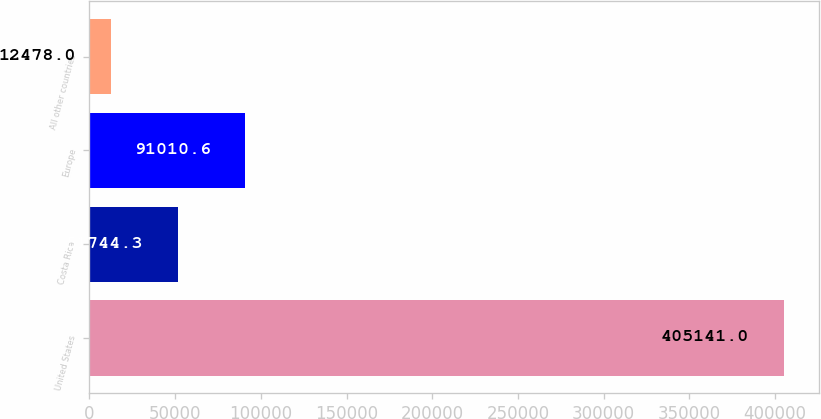Convert chart. <chart><loc_0><loc_0><loc_500><loc_500><bar_chart><fcel>United States<fcel>Costa Rica<fcel>Europe<fcel>All other countries<nl><fcel>405141<fcel>51744.3<fcel>91010.6<fcel>12478<nl></chart> 